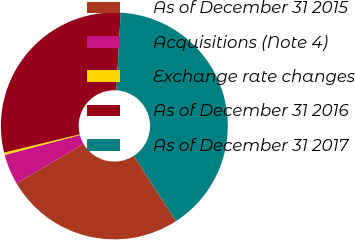Convert chart. <chart><loc_0><loc_0><loc_500><loc_500><pie_chart><fcel>As of December 31 2015<fcel>Acquisitions (Note 4)<fcel>Exchange rate changes<fcel>As of December 31 2016<fcel>As of December 31 2017<nl><fcel>25.71%<fcel>4.31%<fcel>0.35%<fcel>29.67%<fcel>39.96%<nl></chart> 